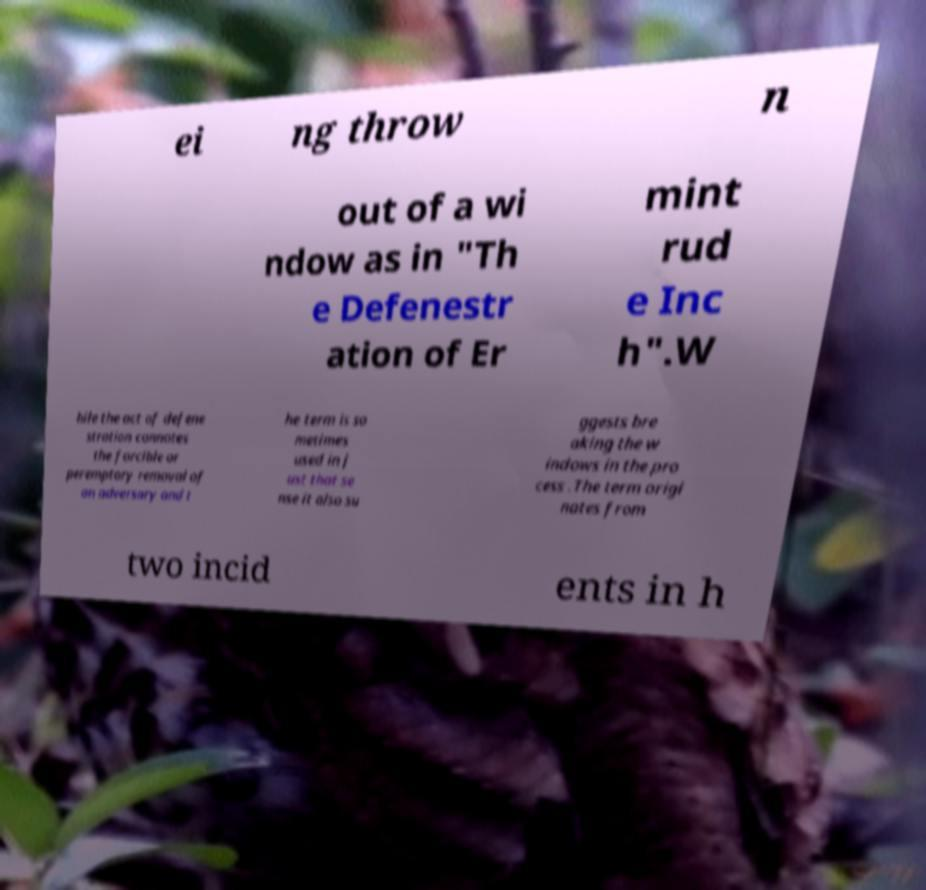For documentation purposes, I need the text within this image transcribed. Could you provide that? ei ng throw n out of a wi ndow as in "Th e Defenestr ation of Er mint rud e Inc h".W hile the act of defene stration connotes the forcible or peremptory removal of an adversary and t he term is so metimes used in j ust that se nse it also su ggests bre aking the w indows in the pro cess .The term origi nates from two incid ents in h 